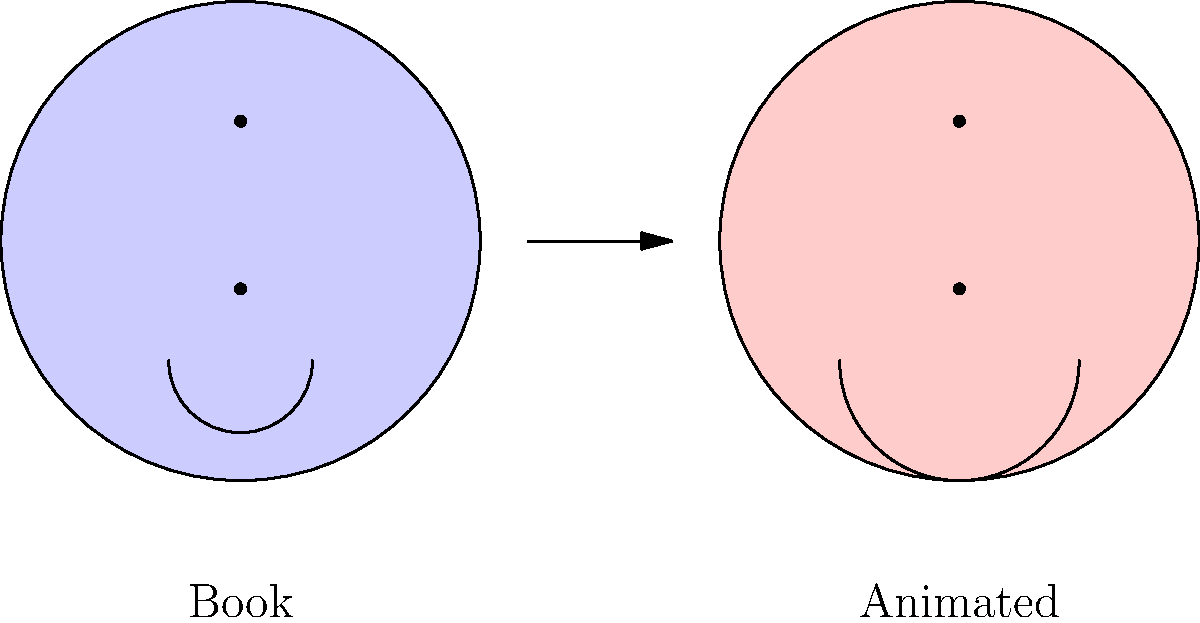Analyze the character designs shown in the illustration above, which represent a popular children's book character before and after animation adaptation. What significant change in the character's facial features suggests a shift in emotional expression, and how might this impact the character's perception by young readers? To answer this question, let's examine the character designs step-by-step:

1. Book character (left):
   - Circular face with subtle features
   - Small, simple smile
   - Overall appearance is calm and neutral

2. Animated character (right):
   - Circular face maintained, but with exaggerated features
   - Significantly larger, more pronounced smile
   - Overall appearance is more expressive and energetic

3. Key difference:
   The most notable change is the size and curvature of the smile. The animated version has a much larger, more exaggerated smile compared to the book version.

4. Impact on emotional expression:
   - The larger smile in the animated version suggests a more overtly happy, excited, or enthusiastic character.
   - This change amplifies the character's positive emotions, making them more obvious and accessible to young viewers.

5. Potential impact on young readers' perception:
   - The exaggerated expression may make the character more appealing and relatable to children.
   - It could potentially simplify the character's emotional range, focusing more on overt happiness.
   - This change might make the character more entertaining in an animated format but could reduce subtlety in emotional portrayal.

6. Considerations for adaptation:
   - The change reflects a common practice in animation to make characters more visually expressive for a moving medium.
   - However, it may alter the original book's portrayal of the character, potentially changing how readers interpret their personality or emotional depth.
Answer: Exaggerated smile in animated version, potentially simplifying emotional range but increasing visual appeal for young viewers. 